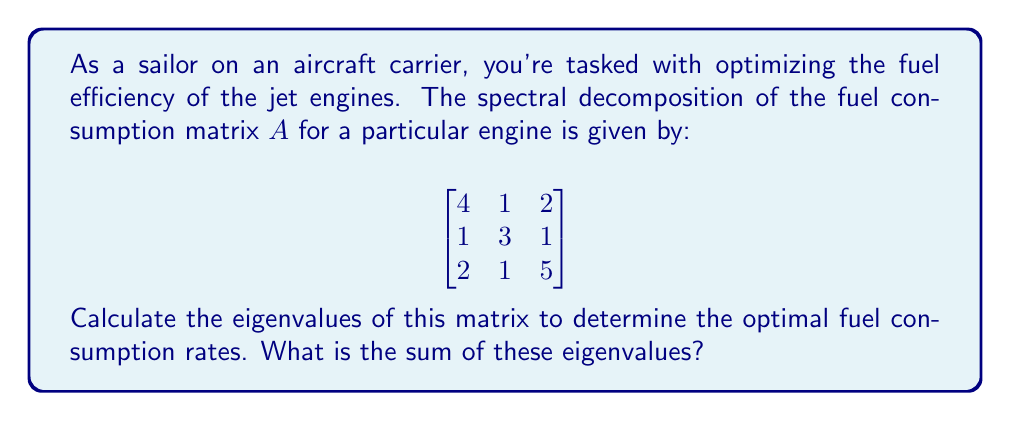Provide a solution to this math problem. To find the eigenvalues of matrix $A$, we need to solve the characteristic equation:

1) First, we calculate $det(A - \lambda I)$:

   $$det\begin{pmatrix}
   4-\lambda & 1 & 2 \\
   1 & 3-\lambda & 1 \\
   2 & 1 & 5-\lambda
   \end{pmatrix} = 0$$

2) Expanding this determinant:

   $(4-\lambda)[(3-\lambda)(5-\lambda)-1] - 1[1(5-\lambda)-2] + 2[1-1(3-\lambda)] = 0$

3) Simplifying:

   $(4-\lambda)[(15-8\lambda+\lambda^2)-1] - [5-\lambda-2] + 2[-2+\lambda] = 0$

   $(4-\lambda)(14-8\lambda+\lambda^2) - 3 + \lambda + 2\lambda - 4 = 0$

4) Expanding further:

   $56-32\lambda+4\lambda^2-14\lambda+8\lambda^2-\lambda^3-3+3\lambda-4 = 0$

5) Collecting terms:

   $-\lambda^3+12\lambda^2-43\lambda+49 = 0$

6) This is the characteristic polynomial. The roots of this polynomial are the eigenvalues.

7) Using the rational root theorem or a computer algebra system, we find the roots are:

   $\lambda_1 = 7$, $\lambda_2 = 3$, $\lambda_3 = 2$

8) The sum of these eigenvalues is:

   $7 + 3 + 2 = 12$

Note: In spectral theory, the sum of eigenvalues is equal to the trace of the matrix (sum of diagonal elements), which provides a quick check: $4 + 3 + 5 = 12$.
Answer: 12 